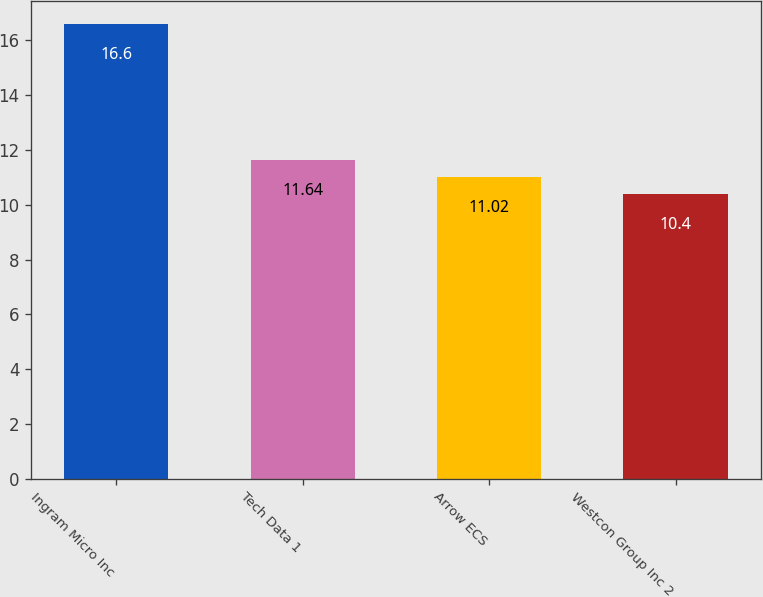Convert chart to OTSL. <chart><loc_0><loc_0><loc_500><loc_500><bar_chart><fcel>Ingram Micro Inc<fcel>Tech Data 1<fcel>Arrow ECS<fcel>Westcon Group Inc 2<nl><fcel>16.6<fcel>11.64<fcel>11.02<fcel>10.4<nl></chart> 